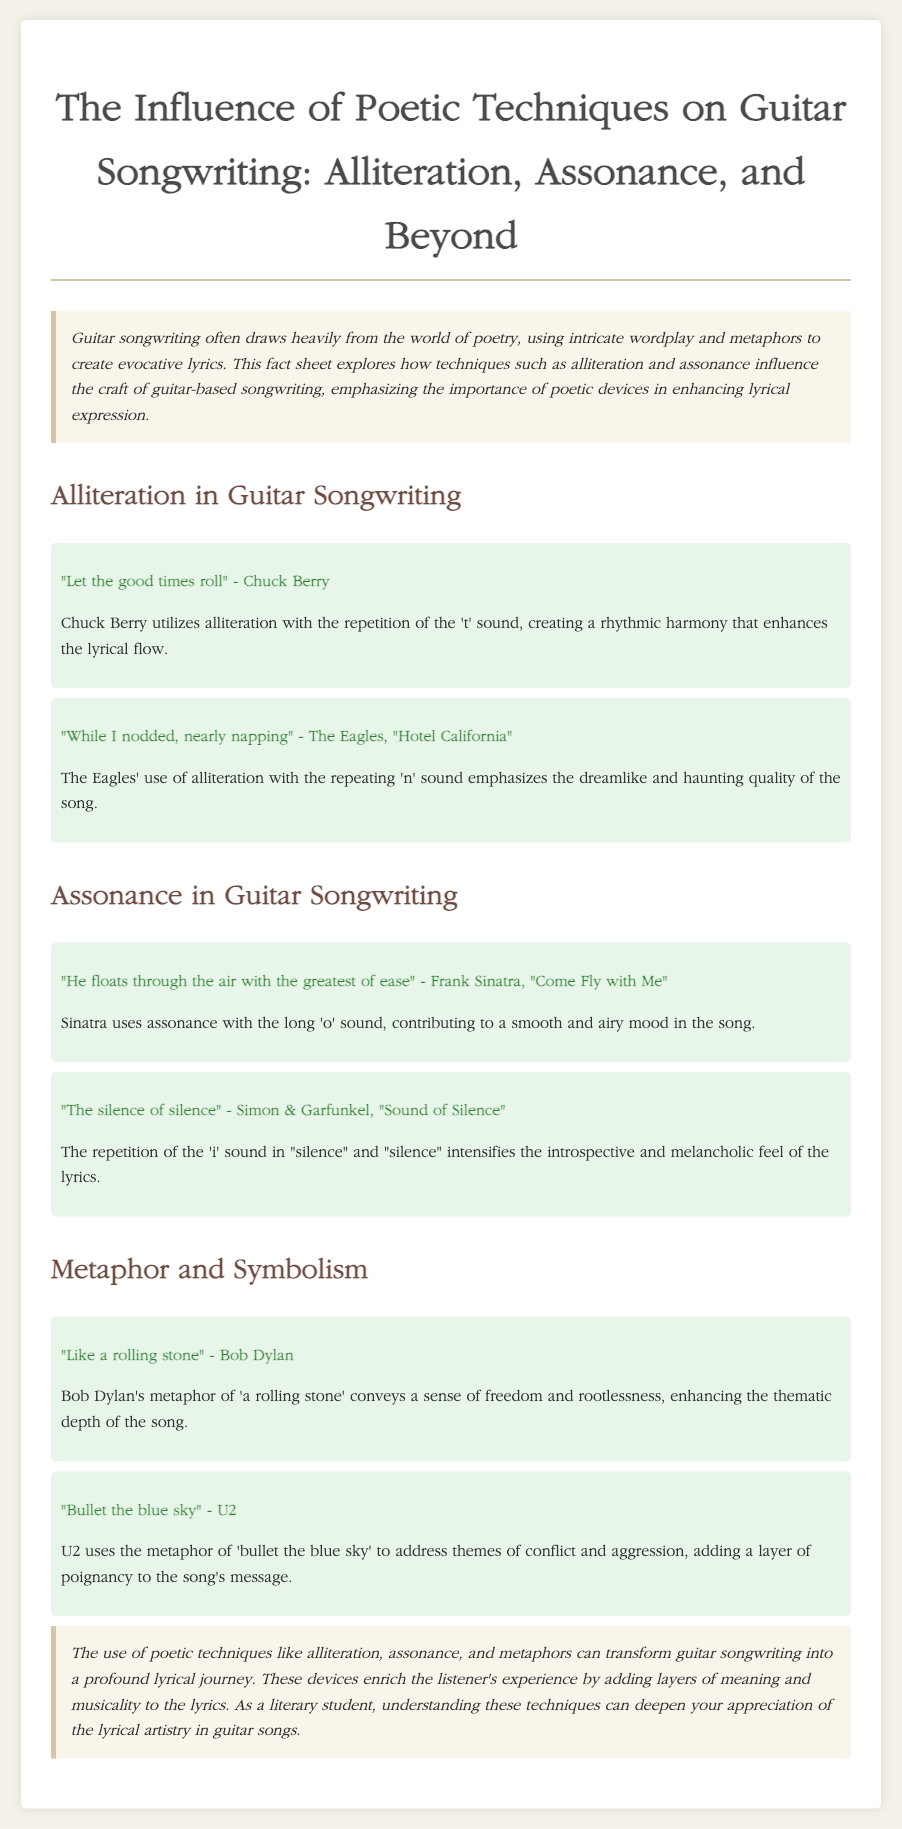What is the main focus of the fact sheet? The fact sheet explores how techniques such as alliteration and assonance influence the craft of guitar-based songwriting.
Answer: Poetic techniques in guitar songwriting Who is quoted in the example of alliteration with "Let the good times roll"? The quote is attributed to Chuck Berry.
Answer: Chuck Berry What sound is repeated in The Eagles' line "While I nodded, nearly napping"? The line features a repetition of the 'n' sound.
Answer: 'n' sound Which poetic technique is illustrated by Sinatra in "Come Fly with Me"? The example demonstrates assonance with a long 'o' sound.
Answer: Assonance What metaphor does Bob Dylan use in his famous song? Bob Dylan's metaphor is "like a rolling stone."
Answer: like a rolling stone What theme does U2's metaphor "bullet the blue sky" address? U2's metaphor addresses themes of conflict and aggression.
Answer: Conflict and aggression What poetic techniques significantly transform guitar songwriting? Alliteration, assonance, and metaphors significantly transform it.
Answer: Alliteration, assonance, and metaphors How does the document characterize the impact of poetic devices on lyrics? The document states that these devices add layers of meaning and musicality to the lyrics.
Answer: Layers of meaning and musicality 